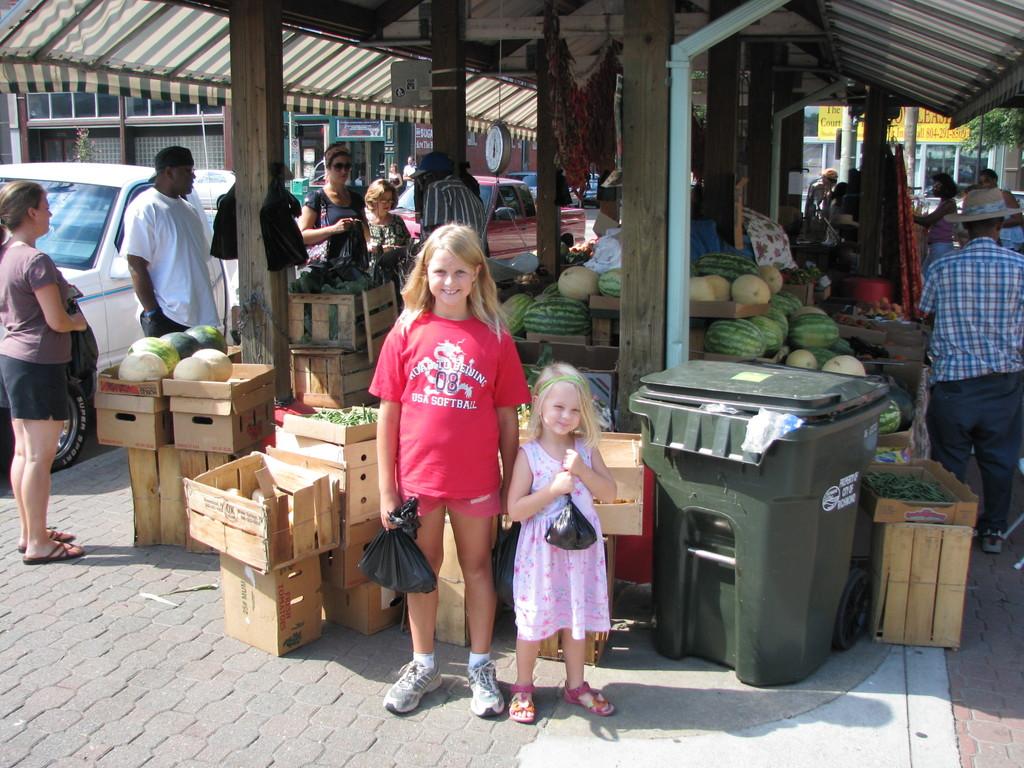What does the front if her shirt say?
Your response must be concise. Usa softball. What are the numbers on the pink shirt?
Give a very brief answer. 08. 